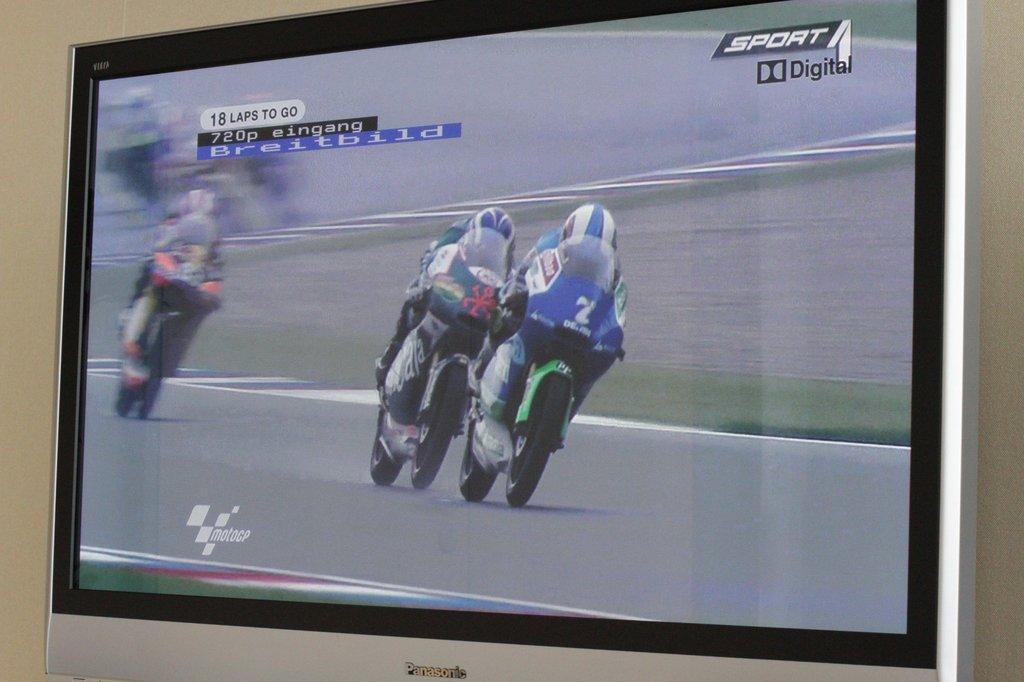Provide a one-sentence caption for the provided image. Screen showing two bikers and the word "Sport Digital" on the top. 